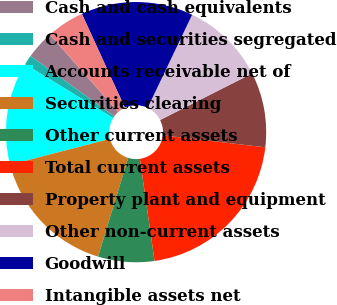<chart> <loc_0><loc_0><loc_500><loc_500><pie_chart><fcel>Cash and cash equivalents<fcel>Cash and securities segregated<fcel>Accounts receivable net of<fcel>Securities clearing<fcel>Other current assets<fcel>Total current assets<fcel>Property plant and equipment<fcel>Other non-current assets<fcel>Goodwill<fcel>Intangible assets net<nl><fcel>3.52%<fcel>1.21%<fcel>12.78%<fcel>16.25%<fcel>6.99%<fcel>20.87%<fcel>9.31%<fcel>10.46%<fcel>13.93%<fcel>4.68%<nl></chart> 